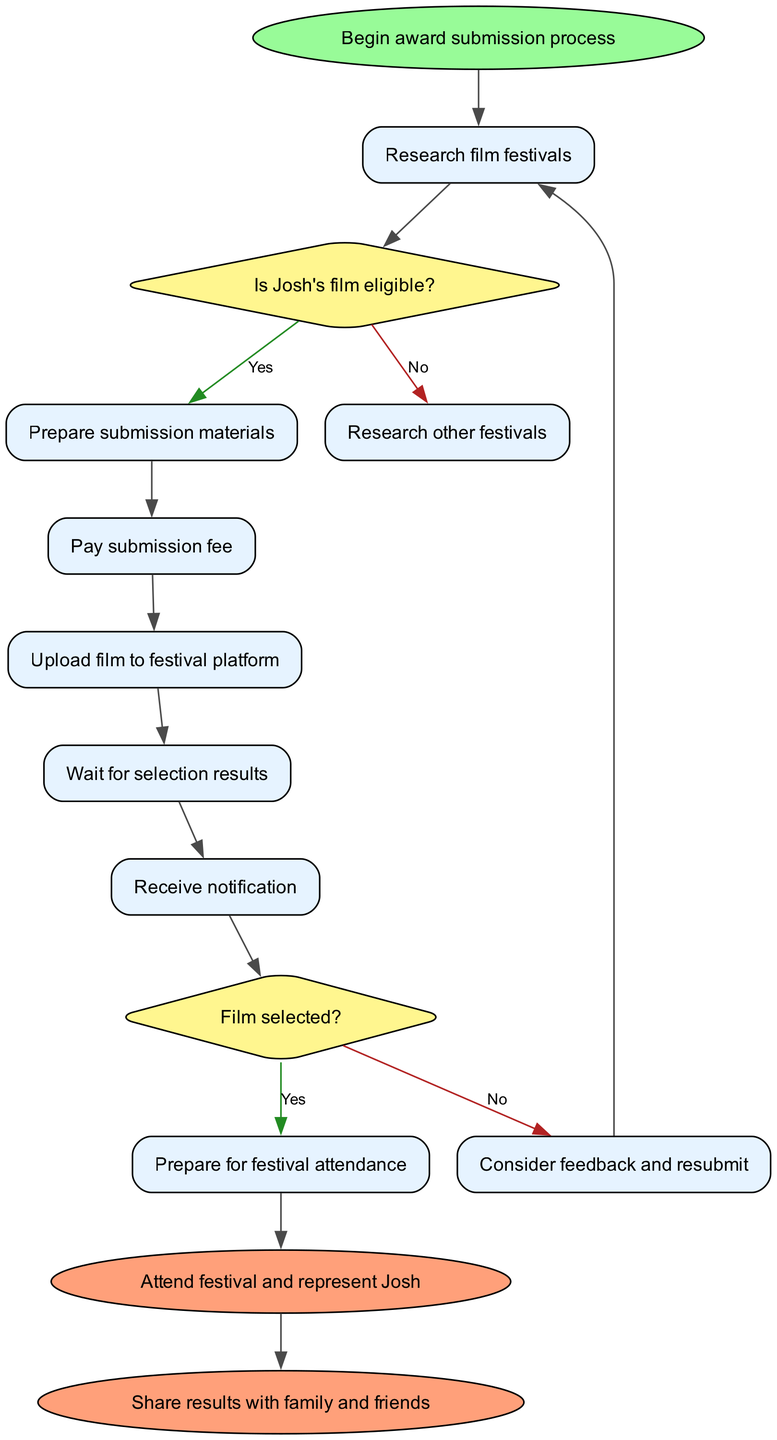What is the starting point of the award submission process? The starting point is marked in the diagram with the label "Begin award submission process," indicating where the flow begins.
Answer: Begin award submission process How many decision nodes are in the diagram? The diagram contains two decision nodes: one for eligibility and another for selection results.
Answer: 2 What is the output if Josh's film is not eligible? If Josh's film is not eligible, according to the decision labeled "Is Josh's film eligible?", the outcome leads to "Research other festivals." This is indicated by the 'No' edge.
Answer: Research other festivals What do you do after receiving a notification? Following the "Receive notification" node in the diagram, a decision must be made about whether the film is selected or not. This means the actions are based on the result received.
Answer: Prepare for festival attendance or Consider feedback and resubmit What comes after uploading the film to the festival platform? The flow shows that after the "Upload film to festival platform" node, the next step is to "Wait for selection results," demonstrating the sequential nature of the process.
Answer: Wait for selection results What is the last step of the process if the film is selected? Upon selection, the flow directs to "Prepare for festival attendance," indicating this is the final action taken in response to a successful result.
Answer: Prepare for festival attendance What happens if feedback is provided after a film is not selected? If feedback is given after the film is not selected, the next action directed by the flow is "Consider feedback and resubmit," which shows a path for improvement.
Answer: Consider feedback and resubmit What is the ultimate goal of the award submission process? The process ultimately leads to two end nodes: "Attend festival and represent Josh" and "Share results with family and friends," showing the outcomes of the submission effort.
Answer: Attend festival and represent Josh or Share results with family and friends What node precedes paying the submission fee? The node preceding the "Pay submission fee" is "Prepare submission materials," indicating the necessary steps before financial commitment.
Answer: Prepare submission materials 